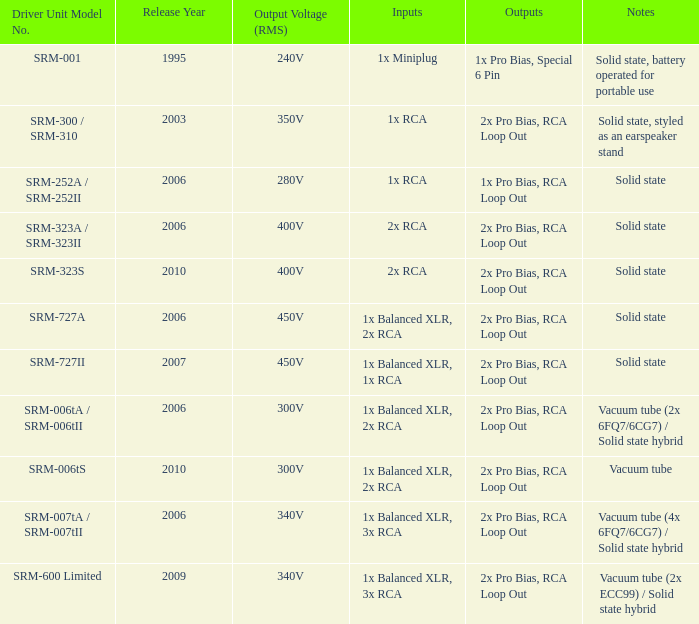How many outputs are there for solid state, battery operated for portable use listed in notes? 1.0. 